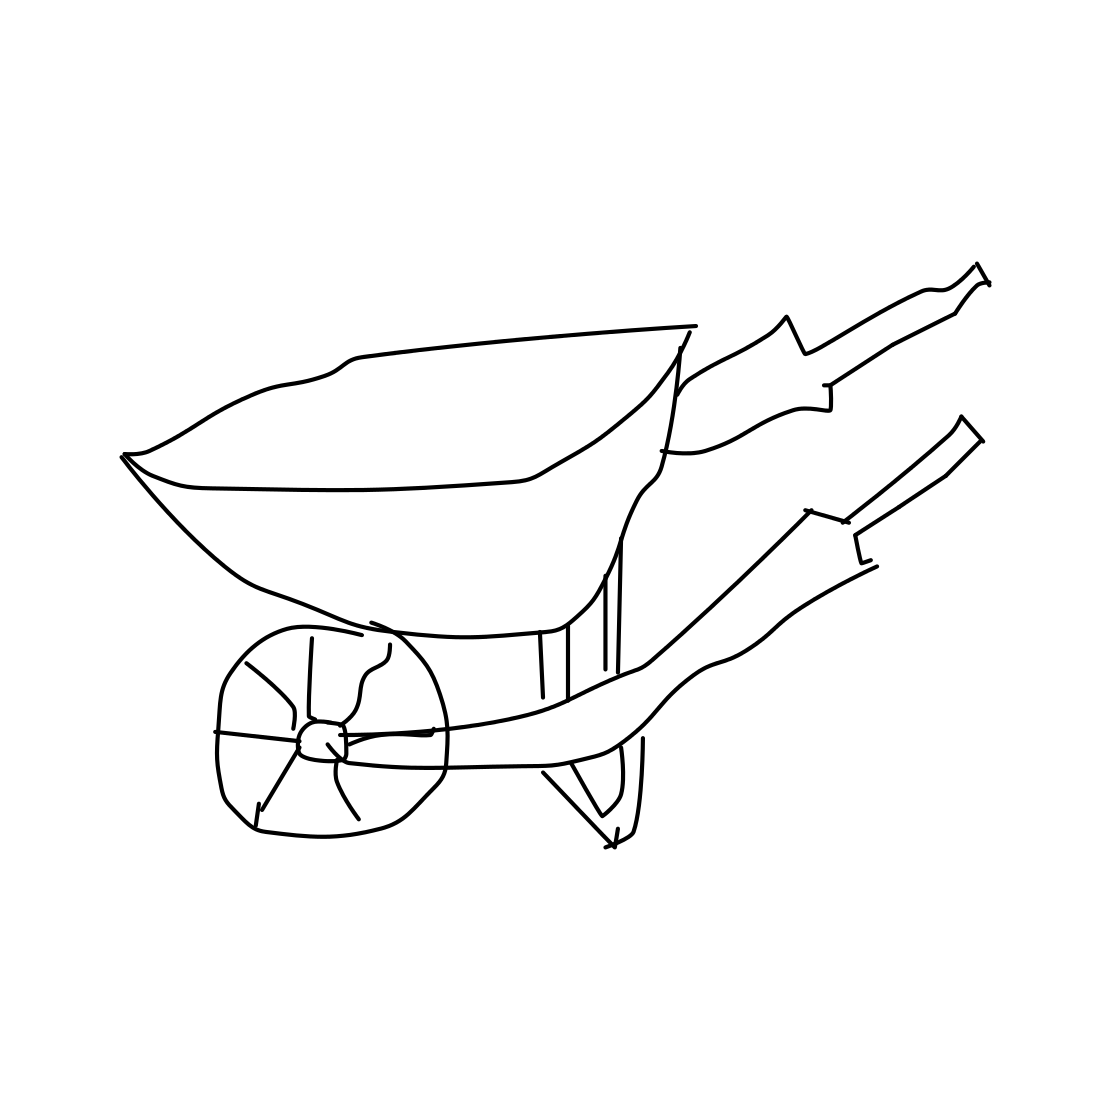Is this a wheelbarrow in the image? Yes, the image indeed shows a wheelbarrow, which is a single-wheeled vehicle typically used for carrying small loads, especially in gardening and construction. It's designed with two handles and legs for support when it's not in motion. 